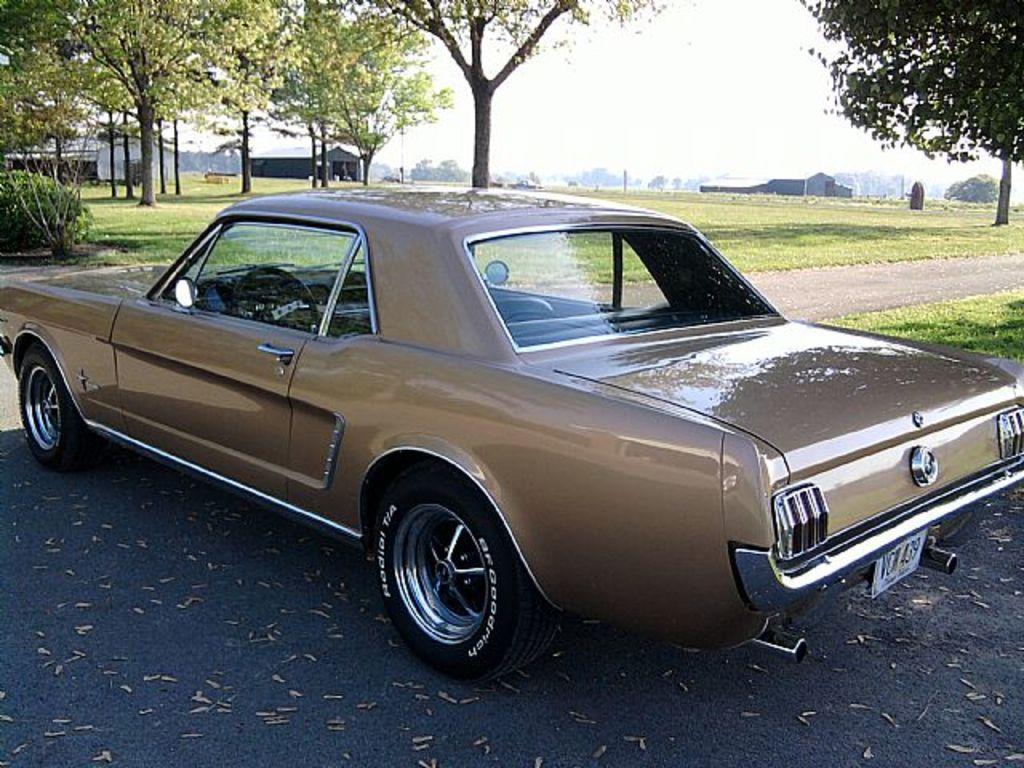Can you describe this image briefly? In this picture I can see a car placed on the road, behind there are some tents, trees, grass and plants. 